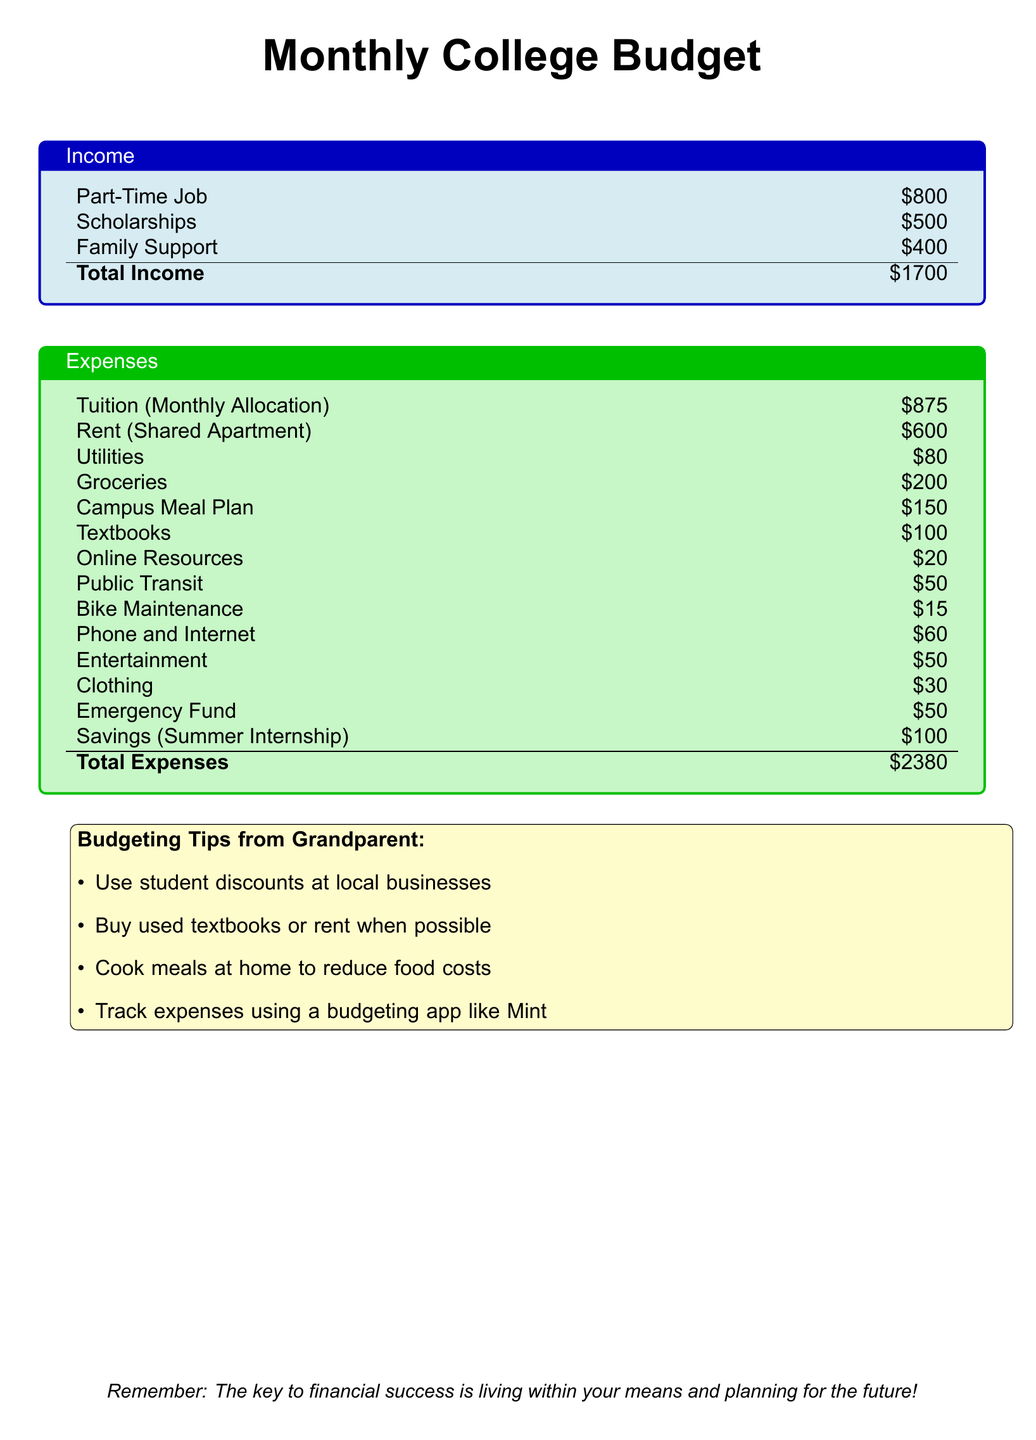What is the total income? The total income is calculated by adding all income sources: Part-Time Job, Scholarships, and Family Support, totaling $800 + $500 + $400 = $1700.
Answer: $1700 What is the monthly tuition allocation? The monthly tuition allocation is listed as an expense in the document, which is $875.
Answer: $875 How much is allocated for rent? The rent allocation is specified in the expenses section, which is $600 for a shared apartment.
Answer: $600 What is the total expenses amount? The total expenses are calculated by summing all the listed expenses, which equals $2380.
Answer: $2380 What is the amount allocated for groceries? The groceries allocation is mentioned in the expenses, set at $200.
Answer: $200 What is one budgeting tip from the grandparent? The document lists several budgeting tips, one example being to "Buy used textbooks or rent when possible."
Answer: Buy used textbooks or rent when possible How much is budgeted for savings for summer internship? The monthly savings allocated for a summer internship is listed as $100.
Answer: $100 What is the budgeted amount for entertainment? The entertainment budget line in the expenses shows an allocation of $50.
Answer: $50 What is the amount allocated for emergency funds? The amount set aside for the emergency fund in the budget is $50.
Answer: $50 